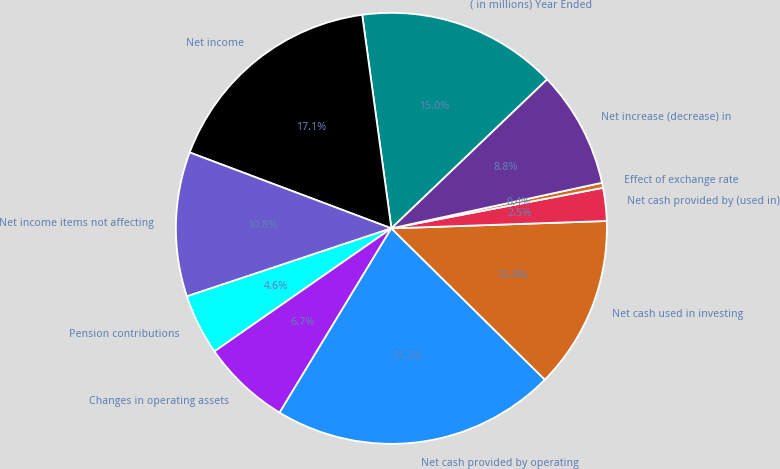<chart> <loc_0><loc_0><loc_500><loc_500><pie_chart><fcel>( in millions) Year Ended<fcel>Net income<fcel>Net income items not affecting<fcel>Pension contributions<fcel>Changes in operating assets<fcel>Net cash provided by operating<fcel>Net cash used in investing<fcel>Net cash provided by (used in)<fcel>Effect of exchange rate<fcel>Net increase (decrease) in<nl><fcel>15.02%<fcel>17.11%<fcel>10.84%<fcel>4.56%<fcel>6.65%<fcel>21.29%<fcel>12.93%<fcel>2.47%<fcel>0.38%<fcel>8.75%<nl></chart> 